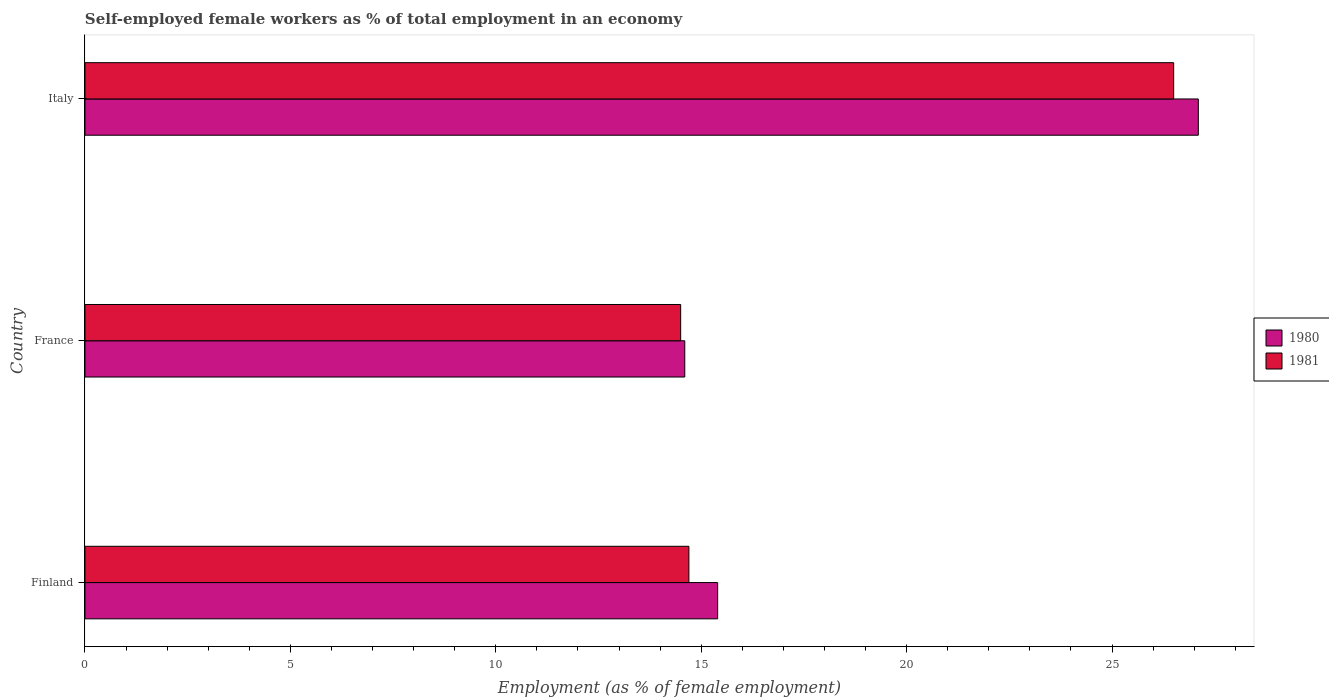How many different coloured bars are there?
Give a very brief answer. 2. Are the number of bars on each tick of the Y-axis equal?
Your response must be concise. Yes. How many bars are there on the 2nd tick from the top?
Keep it short and to the point. 2. What is the percentage of self-employed female workers in 1980 in Italy?
Your answer should be very brief. 27.1. Across all countries, what is the minimum percentage of self-employed female workers in 1980?
Ensure brevity in your answer.  14.6. What is the total percentage of self-employed female workers in 1981 in the graph?
Give a very brief answer. 55.7. What is the difference between the percentage of self-employed female workers in 1980 in Finland and that in France?
Give a very brief answer. 0.8. What is the difference between the percentage of self-employed female workers in 1981 in Finland and the percentage of self-employed female workers in 1980 in France?
Your answer should be very brief. 0.1. What is the average percentage of self-employed female workers in 1981 per country?
Your answer should be compact. 18.57. What is the difference between the percentage of self-employed female workers in 1981 and percentage of self-employed female workers in 1980 in Italy?
Provide a short and direct response. -0.6. What is the ratio of the percentage of self-employed female workers in 1981 in Finland to that in France?
Provide a short and direct response. 1.01. Is the difference between the percentage of self-employed female workers in 1981 in France and Italy greater than the difference between the percentage of self-employed female workers in 1980 in France and Italy?
Give a very brief answer. Yes. What is the difference between the highest and the second highest percentage of self-employed female workers in 1981?
Provide a succinct answer. 11.8. In how many countries, is the percentage of self-employed female workers in 1981 greater than the average percentage of self-employed female workers in 1981 taken over all countries?
Offer a very short reply. 1. What does the 2nd bar from the top in France represents?
Offer a terse response. 1980. How many bars are there?
Make the answer very short. 6. Are all the bars in the graph horizontal?
Ensure brevity in your answer.  Yes. What is the difference between two consecutive major ticks on the X-axis?
Offer a terse response. 5. Does the graph contain any zero values?
Your answer should be very brief. No. How are the legend labels stacked?
Give a very brief answer. Vertical. What is the title of the graph?
Your response must be concise. Self-employed female workers as % of total employment in an economy. What is the label or title of the X-axis?
Your answer should be very brief. Employment (as % of female employment). What is the Employment (as % of female employment) in 1980 in Finland?
Your answer should be compact. 15.4. What is the Employment (as % of female employment) of 1981 in Finland?
Keep it short and to the point. 14.7. What is the Employment (as % of female employment) of 1980 in France?
Keep it short and to the point. 14.6. What is the Employment (as % of female employment) in 1980 in Italy?
Your answer should be compact. 27.1. Across all countries, what is the maximum Employment (as % of female employment) of 1980?
Your answer should be compact. 27.1. Across all countries, what is the maximum Employment (as % of female employment) of 1981?
Offer a very short reply. 26.5. Across all countries, what is the minimum Employment (as % of female employment) in 1980?
Your answer should be very brief. 14.6. What is the total Employment (as % of female employment) in 1980 in the graph?
Give a very brief answer. 57.1. What is the total Employment (as % of female employment) in 1981 in the graph?
Keep it short and to the point. 55.7. What is the difference between the Employment (as % of female employment) in 1980 in Finland and that in France?
Your answer should be compact. 0.8. What is the difference between the Employment (as % of female employment) of 1981 in Finland and that in Italy?
Your answer should be compact. -11.8. What is the difference between the Employment (as % of female employment) of 1981 in France and that in Italy?
Make the answer very short. -12. What is the difference between the Employment (as % of female employment) of 1980 in Finland and the Employment (as % of female employment) of 1981 in Italy?
Ensure brevity in your answer.  -11.1. What is the average Employment (as % of female employment) in 1980 per country?
Provide a short and direct response. 19.03. What is the average Employment (as % of female employment) in 1981 per country?
Keep it short and to the point. 18.57. What is the difference between the Employment (as % of female employment) of 1980 and Employment (as % of female employment) of 1981 in Italy?
Offer a very short reply. 0.6. What is the ratio of the Employment (as % of female employment) in 1980 in Finland to that in France?
Give a very brief answer. 1.05. What is the ratio of the Employment (as % of female employment) of 1981 in Finland to that in France?
Offer a very short reply. 1.01. What is the ratio of the Employment (as % of female employment) of 1980 in Finland to that in Italy?
Keep it short and to the point. 0.57. What is the ratio of the Employment (as % of female employment) in 1981 in Finland to that in Italy?
Provide a succinct answer. 0.55. What is the ratio of the Employment (as % of female employment) of 1980 in France to that in Italy?
Keep it short and to the point. 0.54. What is the ratio of the Employment (as % of female employment) in 1981 in France to that in Italy?
Your response must be concise. 0.55. 